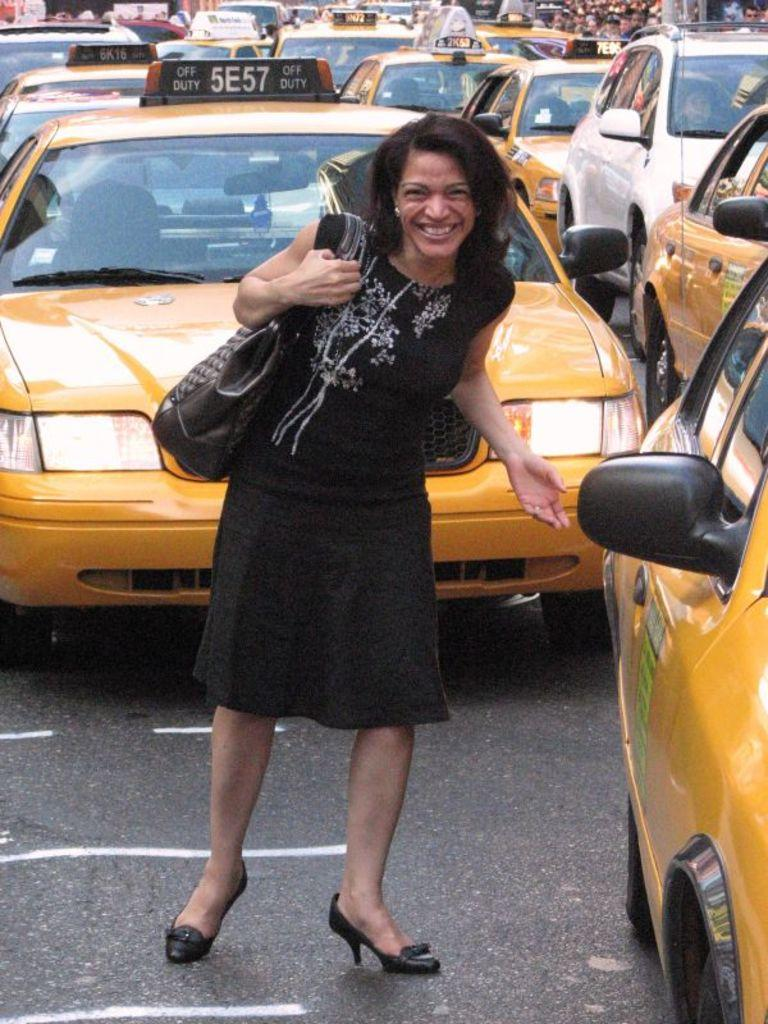<image>
Write a terse but informative summary of the picture. A woman in a black dress, standing in front of the cab marked 5E57, is reaching for the door handle on the cab next to her. 